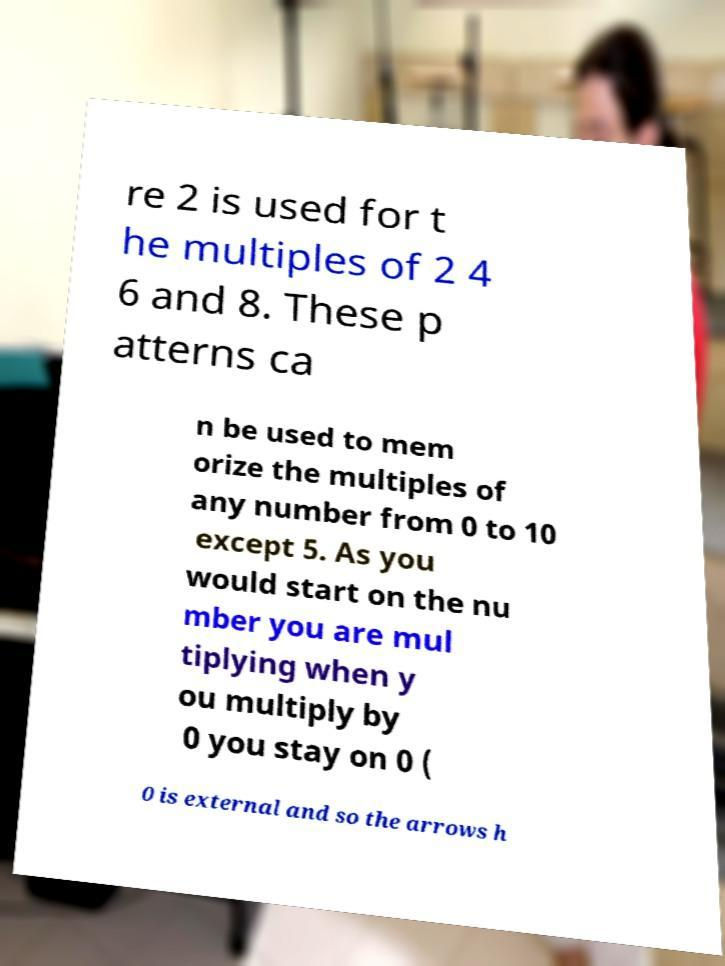For documentation purposes, I need the text within this image transcribed. Could you provide that? re 2 is used for t he multiples of 2 4 6 and 8. These p atterns ca n be used to mem orize the multiples of any number from 0 to 10 except 5. As you would start on the nu mber you are mul tiplying when y ou multiply by 0 you stay on 0 ( 0 is external and so the arrows h 